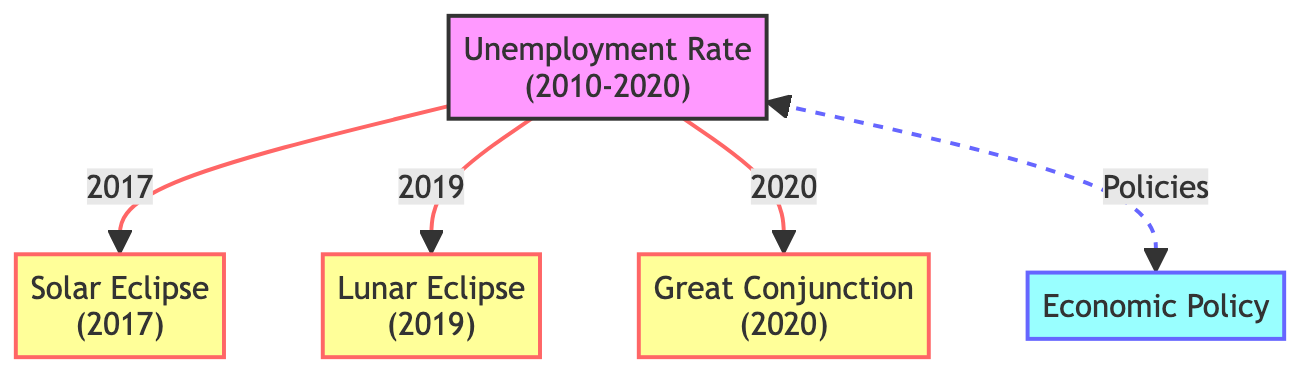What major astronomical event occurred in 2017? The diagram clearly indicates that a solar eclipse took place in 2017, as denoted by the node labeled "Solar Eclipse (2017)."
Answer: Solar Eclipse How many major astronomical events are listed in the diagram? By counting the nodes classified as events, there are three major astronomical events represented in the diagram: the solar eclipse in 2017, the lunar eclipse in 2019, and the great conjunction in 2020.
Answer: 3 What is the relationship between the unemployment rate and economic policy? The diagram illustrates a bi-directional arrow linking the "Unemployment Rate" to "Economic Policy," implying that both the unemployment rate influences economic policies and that these policies can impact the unemployment rate.
Answer: Policies Which year is associated with the lunar eclipse? Referring to the node labeled "Lunar Eclipse (2019)," we can clearly see that it is associated with the year 2019.
Answer: 2019 Which event is represented last in the timeline of astronomical occurrences? The diagram shows that the last major astronomical event in the timeline is the "Great Conjunction (2020)," which is the last node branching off from the unemployment rate.
Answer: Great Conjunction What type of diagram is this? The structure and content of the diagram, which connects economic concepts to astronomical events, classifies it as an Astronomy Diagram, linking unemployment impacts to celestial occurrences.
Answer: Astronomy Diagram How does the unemployment rate relate to the solar eclipse? The diagram has a direct arrow connecting "Unemployment Rate" to "Solar Eclipse (2017)," indicating a specific relationship to that year, effectively showing the unemployment rate in relation to the solar eclipse event.
Answer: 2017 What color classification is used for economic policy? According to the diagram, economic policy is represented in a blue color scheme, specifically defined as 'fill:#9ff' and 'stroke:#66f' in the policy classification.
Answer: Blue 